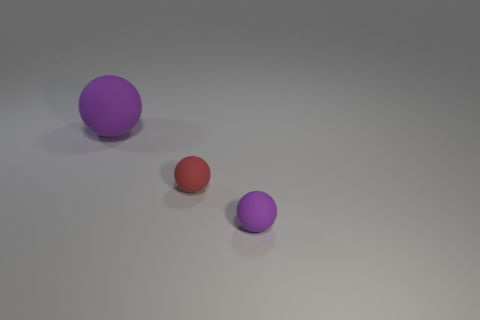Add 3 spheres. How many objects exist? 6 Subtract 0 gray blocks. How many objects are left? 3 Subtract all large objects. Subtract all large spheres. How many objects are left? 1 Add 3 red rubber things. How many red rubber things are left? 4 Add 3 matte balls. How many matte balls exist? 6 